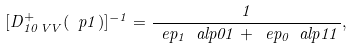Convert formula to latex. <formula><loc_0><loc_0><loc_500><loc_500>[ D ^ { + } _ { 1 0 \, V V } ( \ p { 1 } ) ] ^ { - 1 } = \frac { 1 } { \ e p _ { 1 } \ a l p { 0 } { 1 } + \ e p _ { 0 } \ a l p { 1 } { 1 } } ,</formula> 